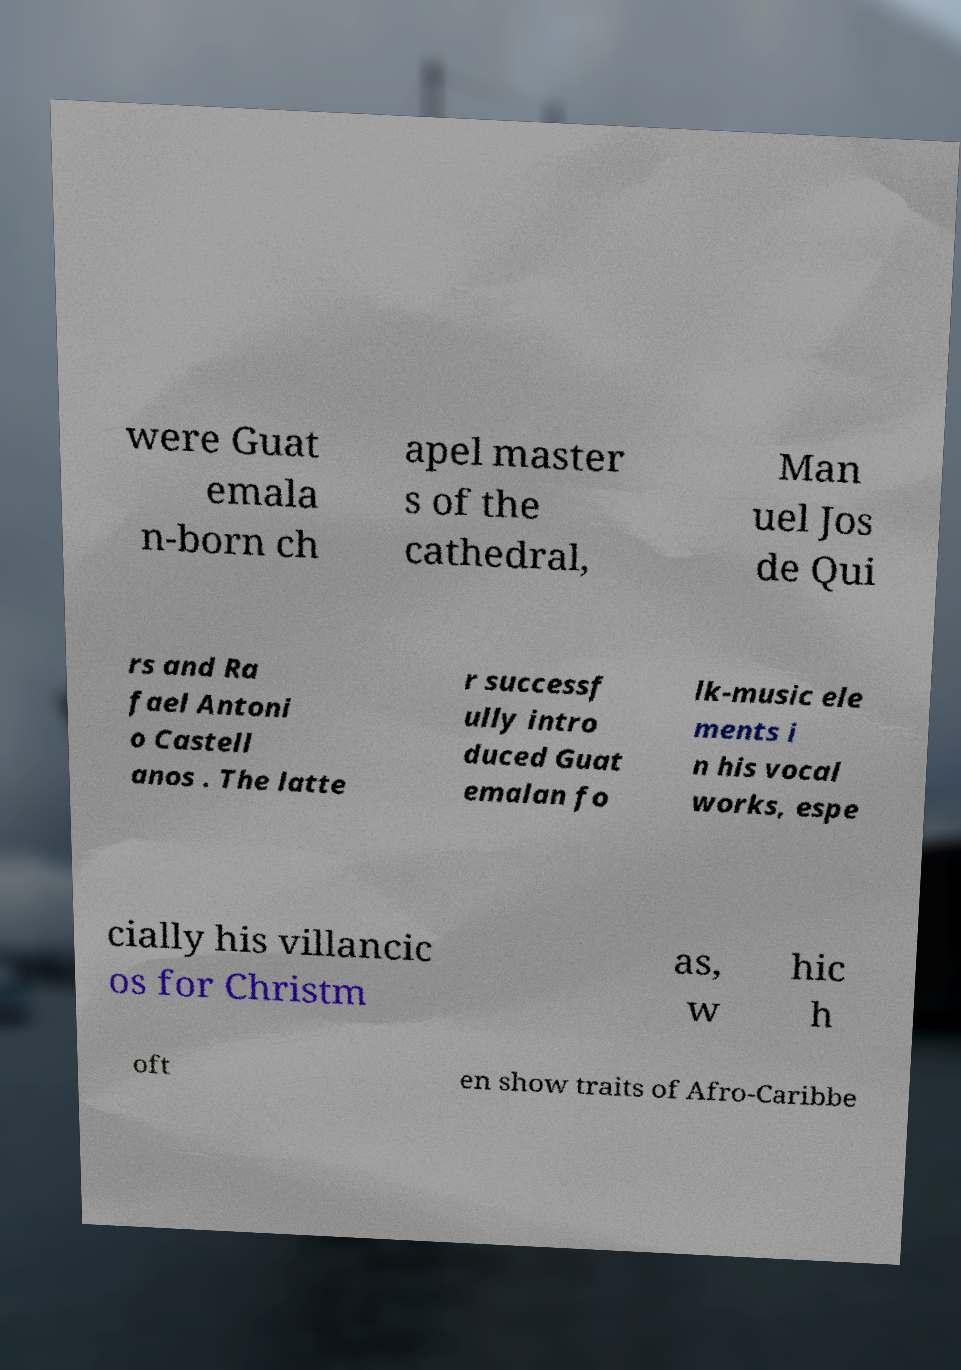For documentation purposes, I need the text within this image transcribed. Could you provide that? were Guat emala n-born ch apel master s of the cathedral, Man uel Jos de Qui rs and Ra fael Antoni o Castell anos . The latte r successf ully intro duced Guat emalan fo lk-music ele ments i n his vocal works, espe cially his villancic os for Christm as, w hic h oft en show traits of Afro-Caribbe 